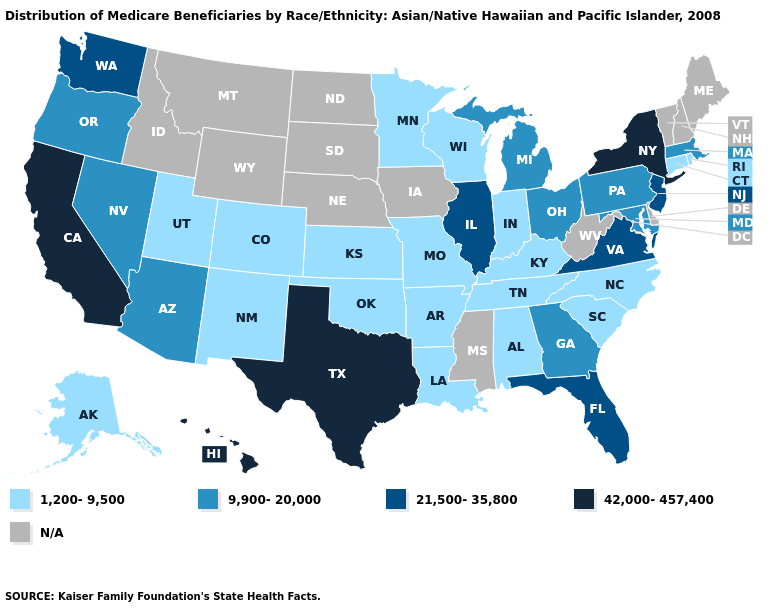Which states have the lowest value in the West?
Concise answer only. Alaska, Colorado, New Mexico, Utah. Which states have the highest value in the USA?
Short answer required. California, Hawaii, New York, Texas. What is the value of Alabama?
Write a very short answer. 1,200-9,500. Name the states that have a value in the range 9,900-20,000?
Quick response, please. Arizona, Georgia, Maryland, Massachusetts, Michigan, Nevada, Ohio, Oregon, Pennsylvania. Name the states that have a value in the range 9,900-20,000?
Keep it brief. Arizona, Georgia, Maryland, Massachusetts, Michigan, Nevada, Ohio, Oregon, Pennsylvania. What is the value of Idaho?
Quick response, please. N/A. Name the states that have a value in the range N/A?
Write a very short answer. Delaware, Idaho, Iowa, Maine, Mississippi, Montana, Nebraska, New Hampshire, North Dakota, South Dakota, Vermont, West Virginia, Wyoming. What is the value of Vermont?
Answer briefly. N/A. What is the highest value in the MidWest ?
Give a very brief answer. 21,500-35,800. Name the states that have a value in the range 1,200-9,500?
Quick response, please. Alabama, Alaska, Arkansas, Colorado, Connecticut, Indiana, Kansas, Kentucky, Louisiana, Minnesota, Missouri, New Mexico, North Carolina, Oklahoma, Rhode Island, South Carolina, Tennessee, Utah, Wisconsin. Name the states that have a value in the range 1,200-9,500?
Concise answer only. Alabama, Alaska, Arkansas, Colorado, Connecticut, Indiana, Kansas, Kentucky, Louisiana, Minnesota, Missouri, New Mexico, North Carolina, Oklahoma, Rhode Island, South Carolina, Tennessee, Utah, Wisconsin. What is the value of Kentucky?
Give a very brief answer. 1,200-9,500. What is the highest value in the Northeast ?
Be succinct. 42,000-457,400. 